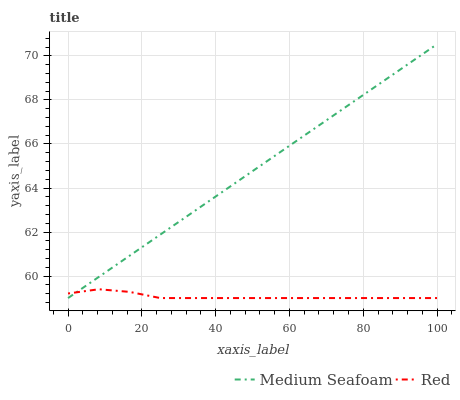Does Red have the minimum area under the curve?
Answer yes or no. Yes. Does Medium Seafoam have the maximum area under the curve?
Answer yes or no. Yes. Does Red have the maximum area under the curve?
Answer yes or no. No. Is Medium Seafoam the smoothest?
Answer yes or no. Yes. Is Red the roughest?
Answer yes or no. Yes. Is Red the smoothest?
Answer yes or no. No. Does Medium Seafoam have the lowest value?
Answer yes or no. Yes. Does Medium Seafoam have the highest value?
Answer yes or no. Yes. Does Red have the highest value?
Answer yes or no. No. Does Red intersect Medium Seafoam?
Answer yes or no. Yes. Is Red less than Medium Seafoam?
Answer yes or no. No. Is Red greater than Medium Seafoam?
Answer yes or no. No. 